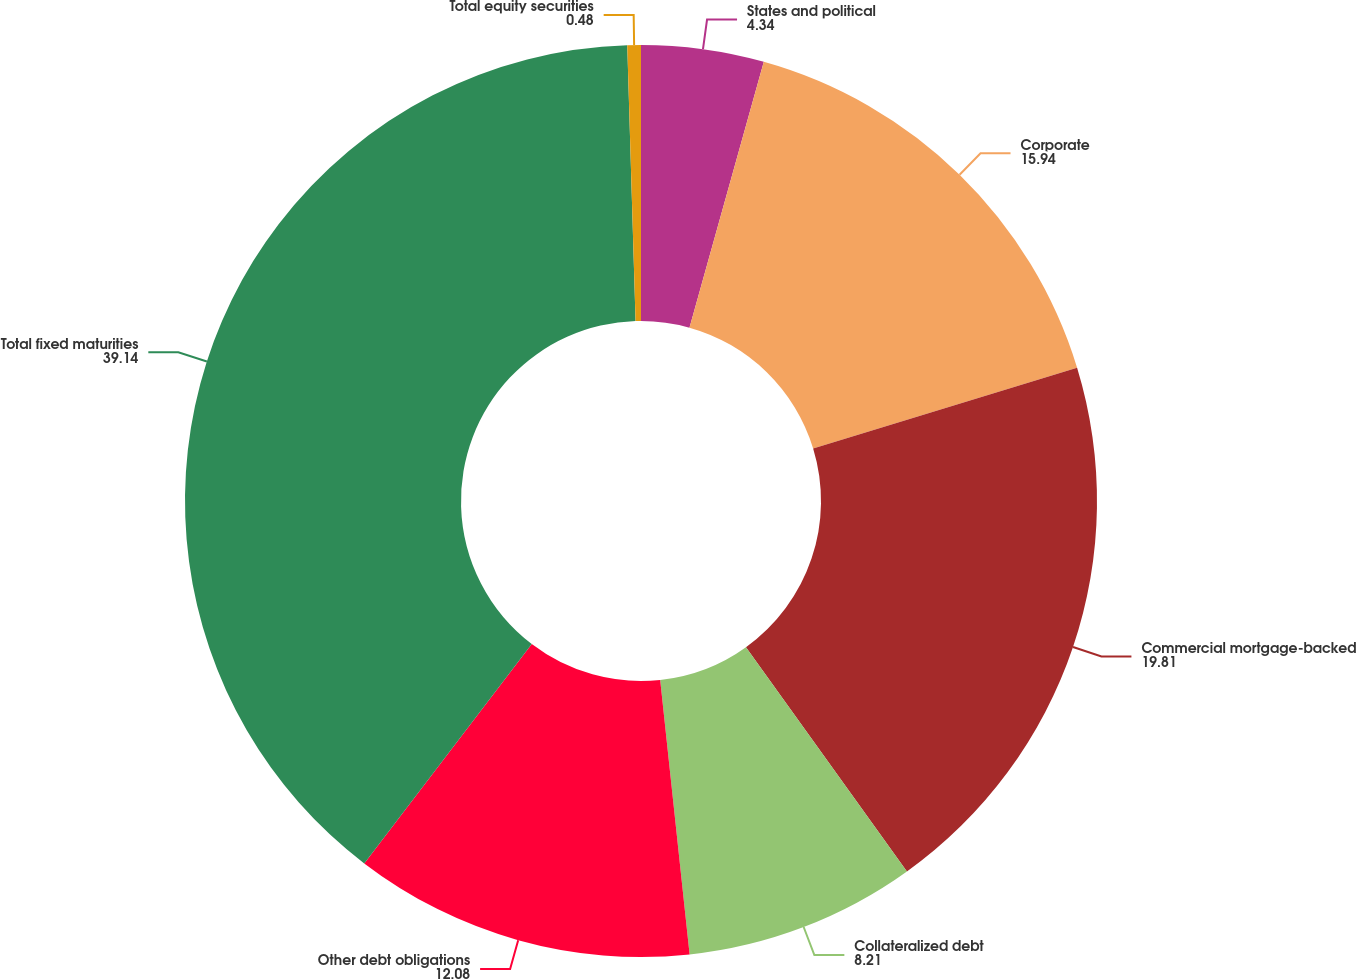Convert chart. <chart><loc_0><loc_0><loc_500><loc_500><pie_chart><fcel>States and political<fcel>Corporate<fcel>Commercial mortgage-backed<fcel>Collateralized debt<fcel>Other debt obligations<fcel>Total fixed maturities<fcel>Total equity securities<nl><fcel>4.34%<fcel>15.94%<fcel>19.81%<fcel>8.21%<fcel>12.08%<fcel>39.14%<fcel>0.48%<nl></chart> 